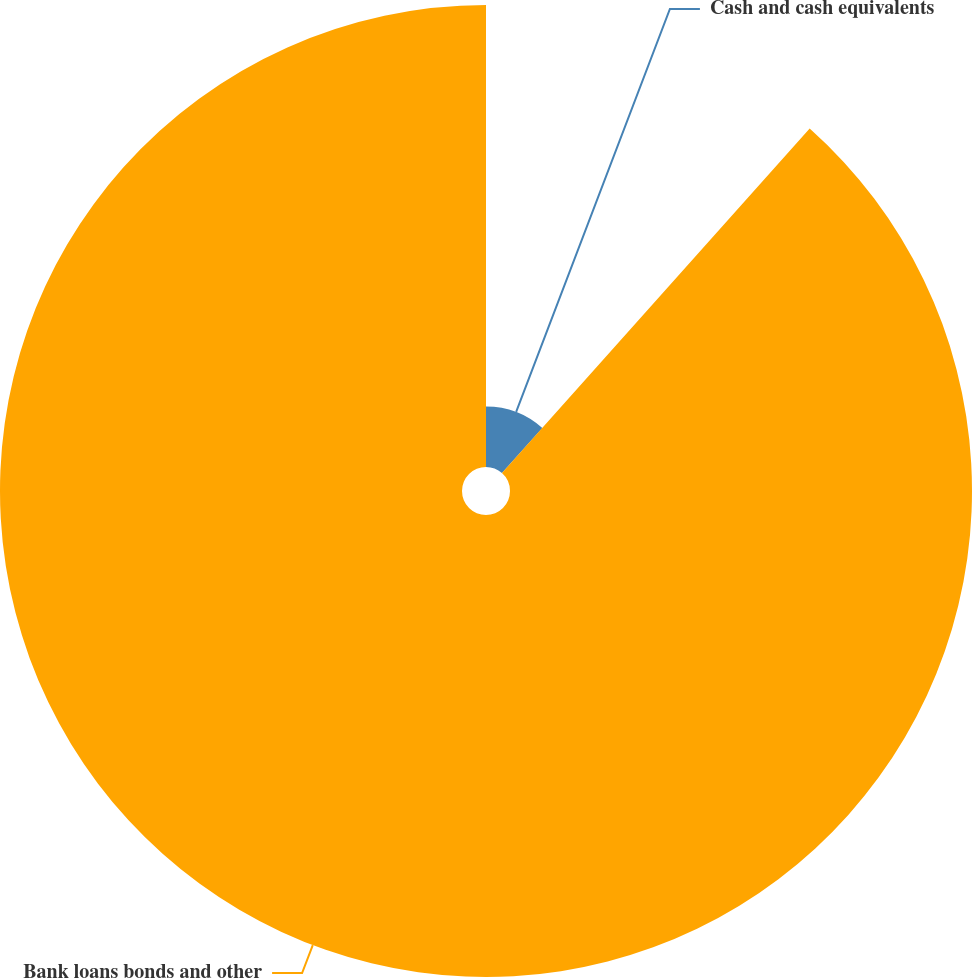<chart> <loc_0><loc_0><loc_500><loc_500><pie_chart><fcel>Cash and cash equivalents<fcel>Bank loans bonds and other<nl><fcel>11.6%<fcel>88.4%<nl></chart> 